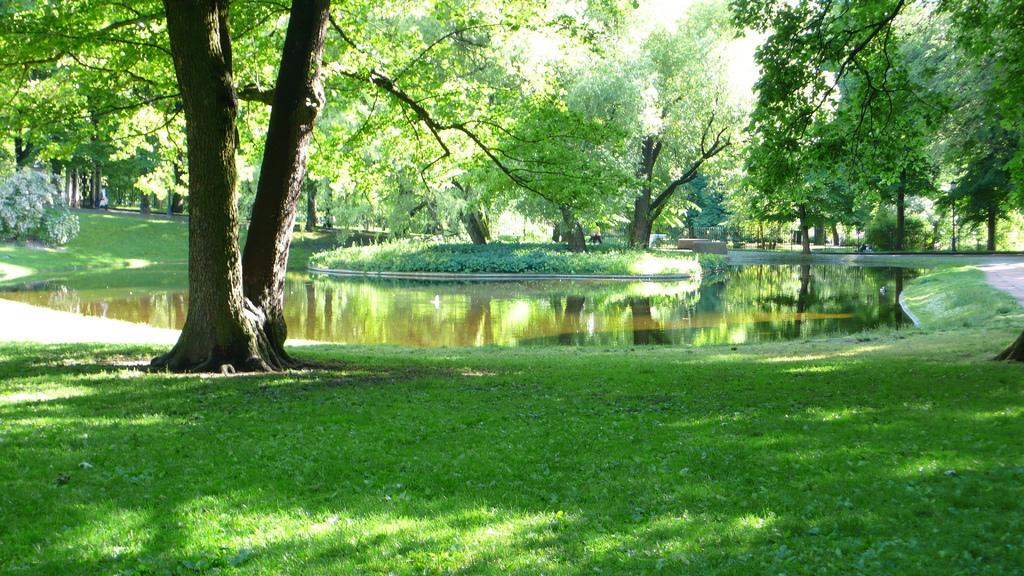What is the main setting of the image? The main setting of the image is an open grass ground. Are there any other natural elements present on the grass ground? Yes, there are multiple trees on the grass ground. What is the central feature of the grass ground? There is water in the center of the grass ground. What type of education is being provided in the image? There is no indication of any educational activity in the image; it primarily features an open grass ground with trees and water. 